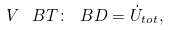Convert formula to latex. <formula><loc_0><loc_0><loc_500><loc_500>V \, { \ B T } \colon { \ B D } = \dot { U } _ { t o t } ,</formula> 